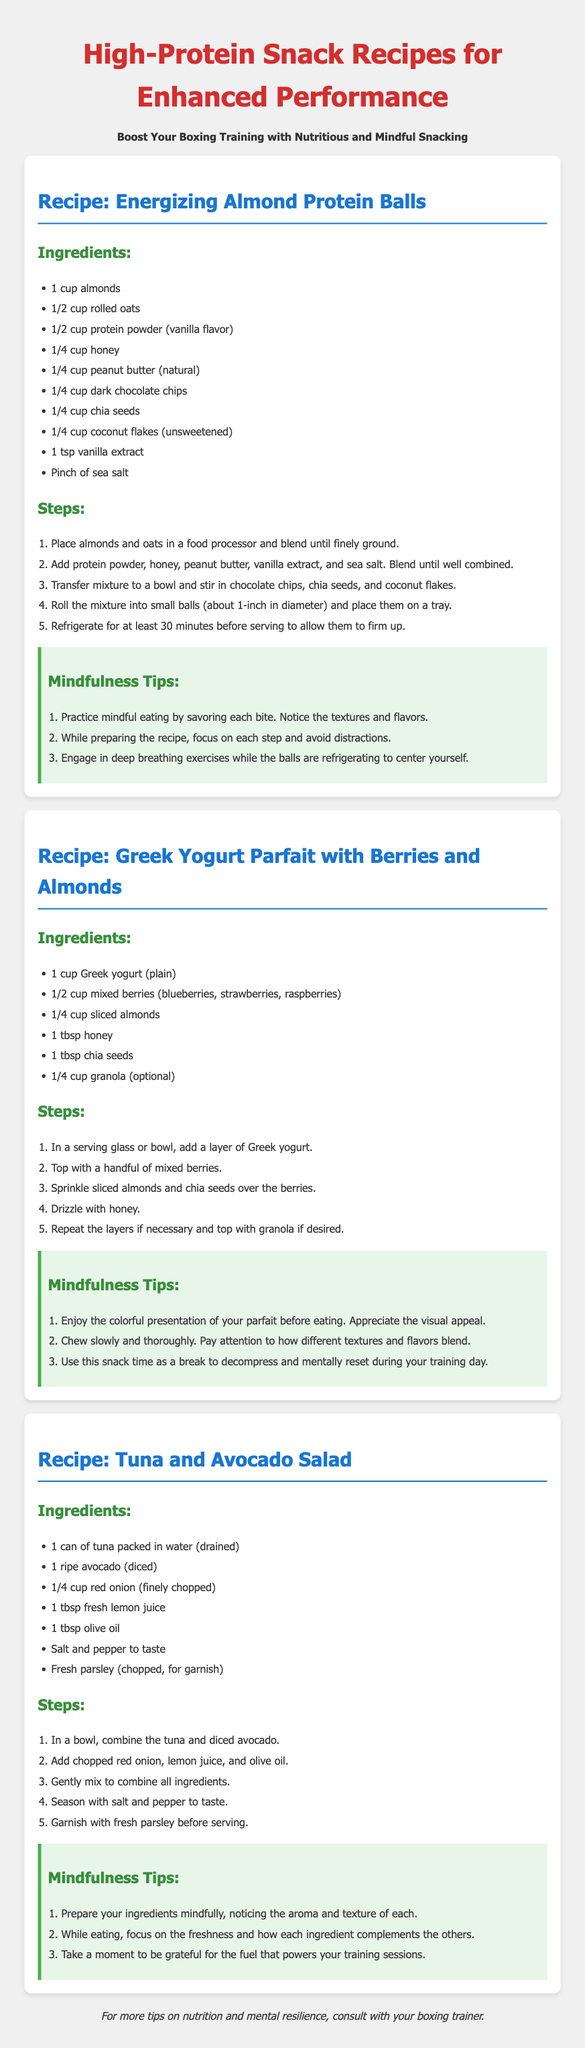What is the title of the document? The title is the main heading of the document reflecting its content.
Answer: High-Protein Snack Recipes for Enhanced Performance How many ingredients are in the Energizing Almond Protein Balls recipe? The total ingredients are listed under the respective recipe, which counts to nine items.
Answer: 10 What flavor should the protein powder be for the Almond Protein Balls? The specific flavor is mentioned as part of the ingredients list for that recipe.
Answer: vanilla flavor What type of fish is used in the Tuna and Avocado Salad? The specific type of fish used is mentioned as the main ingredient in the salad recipe.
Answer: tuna How long should the Almond Protein Balls be refrigerated? The preparation step states the required time for chilling the balls to firm up.
Answer: 30 minutes What is a garnish suggested for the Tuna and Avocado Salad? The recommended garnish is noted in the final steps of the salad recipe preparation.
Answer: fresh parsley How many layers are suggested for the Greek Yogurt Parfait? The recipe suggests a method of layering the ingredients, allowing repeats to create the parfait.
Answer: repeat the layers if necessary 